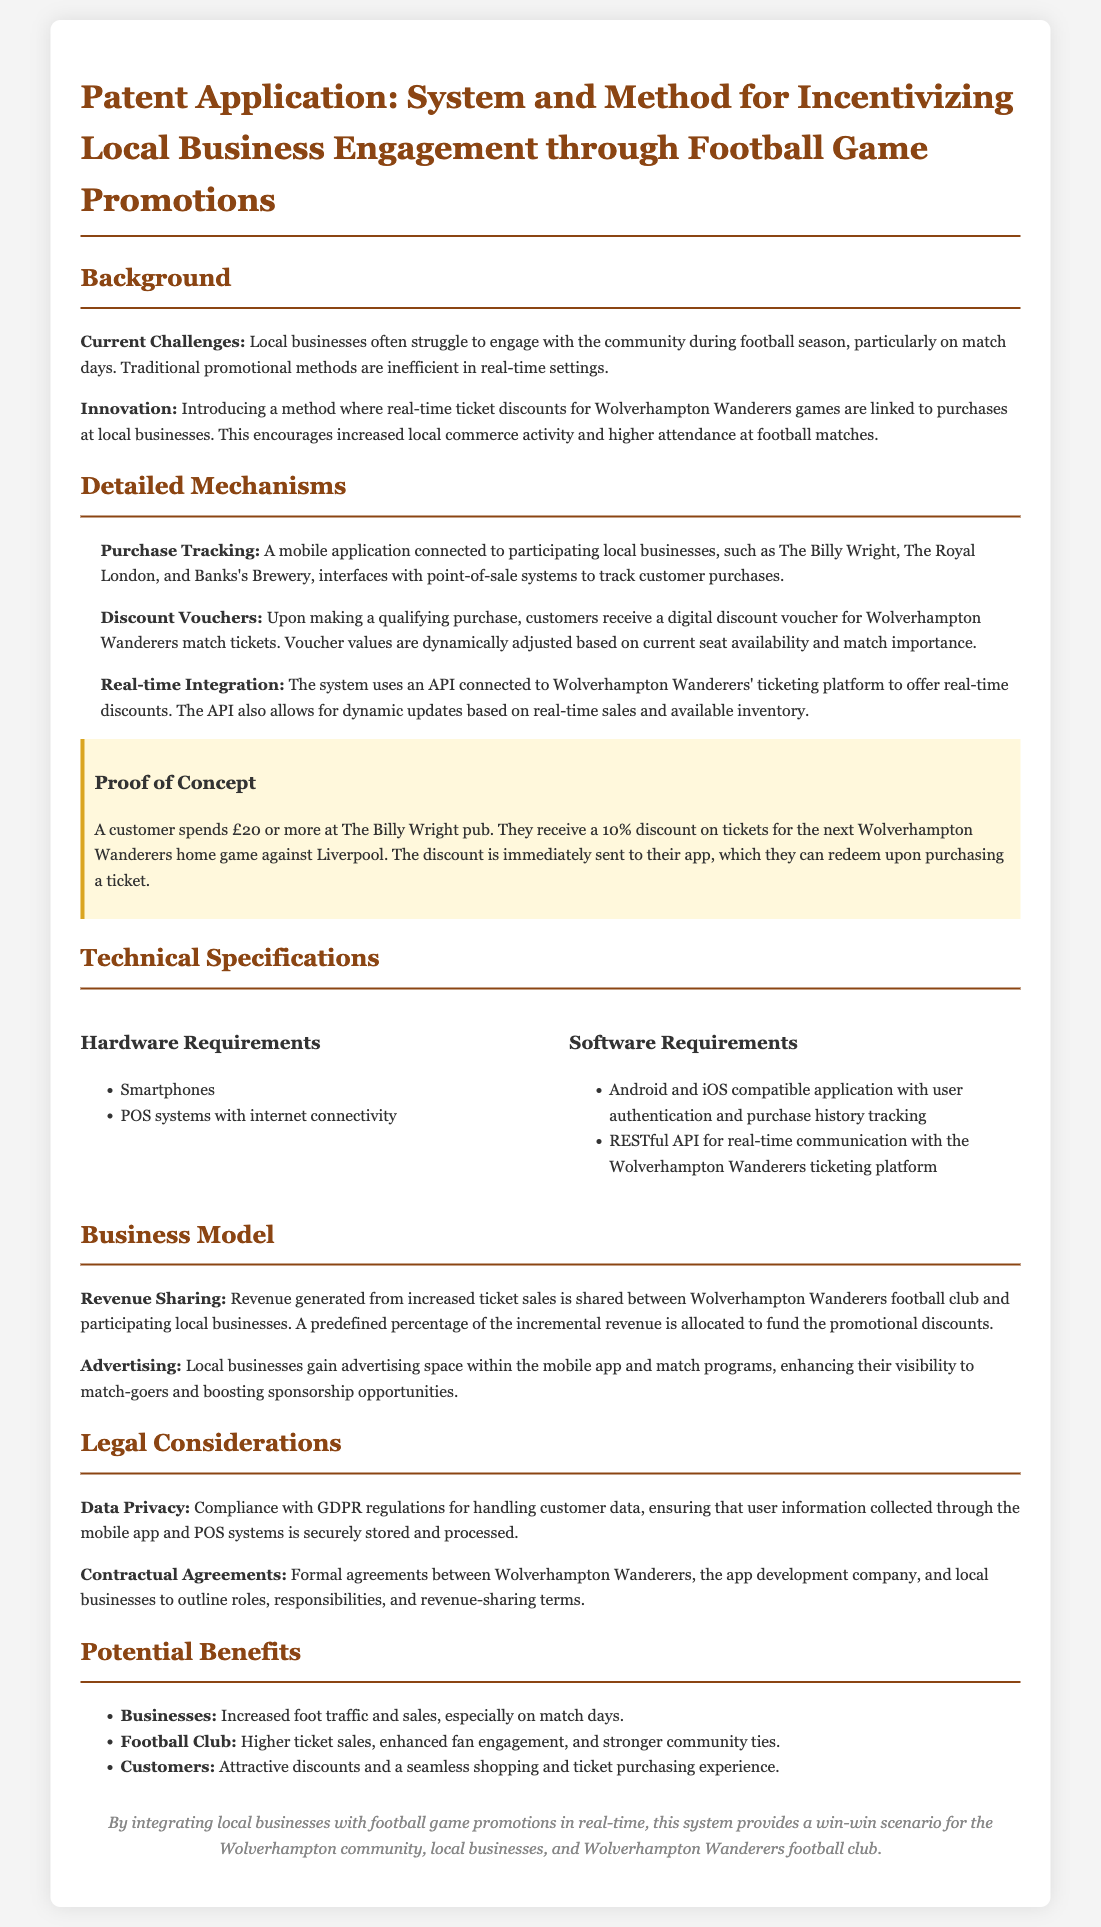What is the main innovation proposed in the patent? The innovation is a method where real-time ticket discounts for Wolverhampton Wanderers games are linked to purchases at local businesses.
Answer: ticket discounts linked to purchases What local business is mentioned as a participant in the program? The document provides examples of local businesses participating in the program, including The Billy Wright pub.
Answer: The Billy Wright What percentage discount is given for a £20 purchase? The document states that a customer spending £20 or more receives a 10% discount on tickets.
Answer: 10% What is the purpose of the mobile application in this system? The mobile application connects to local businesses and tracks customer purchases to provide discount vouchers for match tickets.
Answer: track purchases What revenue-sharing model is described? The document outlines that revenue generated from increased ticket sales is shared between Wolverhampton Wanderers club and local businesses.
Answer: revenue sharing What technical requirement is specified for the application? The software requirement highlights that the application must be compatible with Android and iOS.
Answer: Android and iOS compatible Which legal regulation is mentioned concerning data privacy? The patent mentions compliance with GDPR regulations for handling customer data.
Answer: GDPR regulations What is one potential benefit for the football club? One benefit mentioned is higher ticket sales resulting from increased local business engagement.
Answer: higher ticket sales 